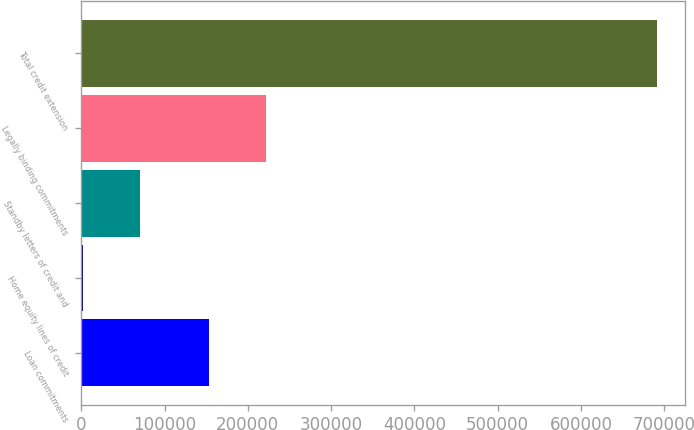Convert chart. <chart><loc_0><loc_0><loc_500><loc_500><bar_chart><fcel>Loan commitments<fcel>Home equity lines of credit<fcel>Standby letters of credit and<fcel>Legally binding commitments<fcel>Total credit extension<nl><fcel>152926<fcel>1722<fcel>70618.7<fcel>221823<fcel>690689<nl></chart> 